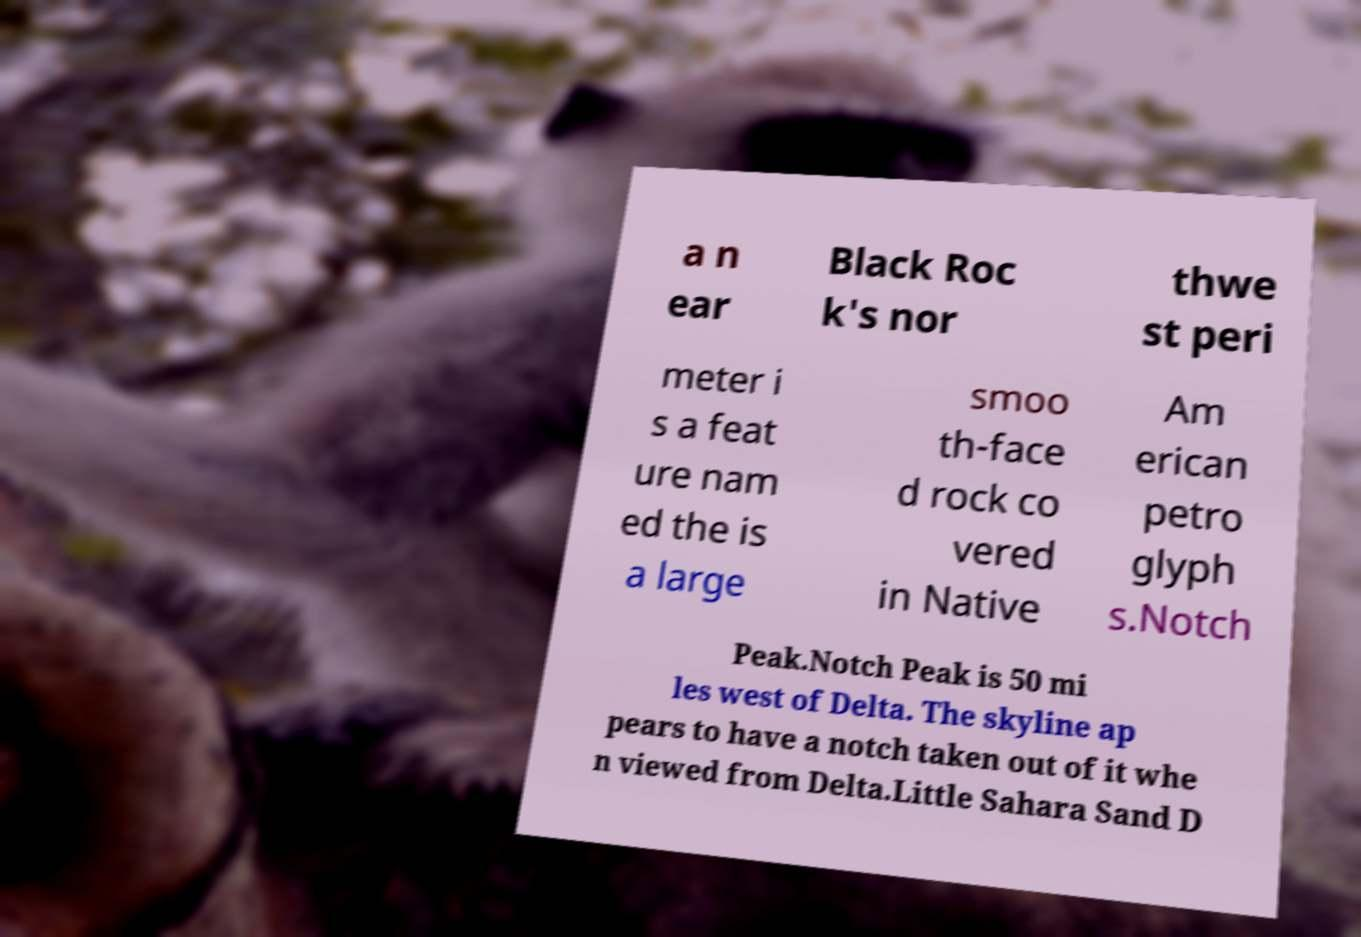Could you extract and type out the text from this image? a n ear Black Roc k's nor thwe st peri meter i s a feat ure nam ed the is a large smoo th-face d rock co vered in Native Am erican petro glyph s.Notch Peak.Notch Peak is 50 mi les west of Delta. The skyline ap pears to have a notch taken out of it whe n viewed from Delta.Little Sahara Sand D 